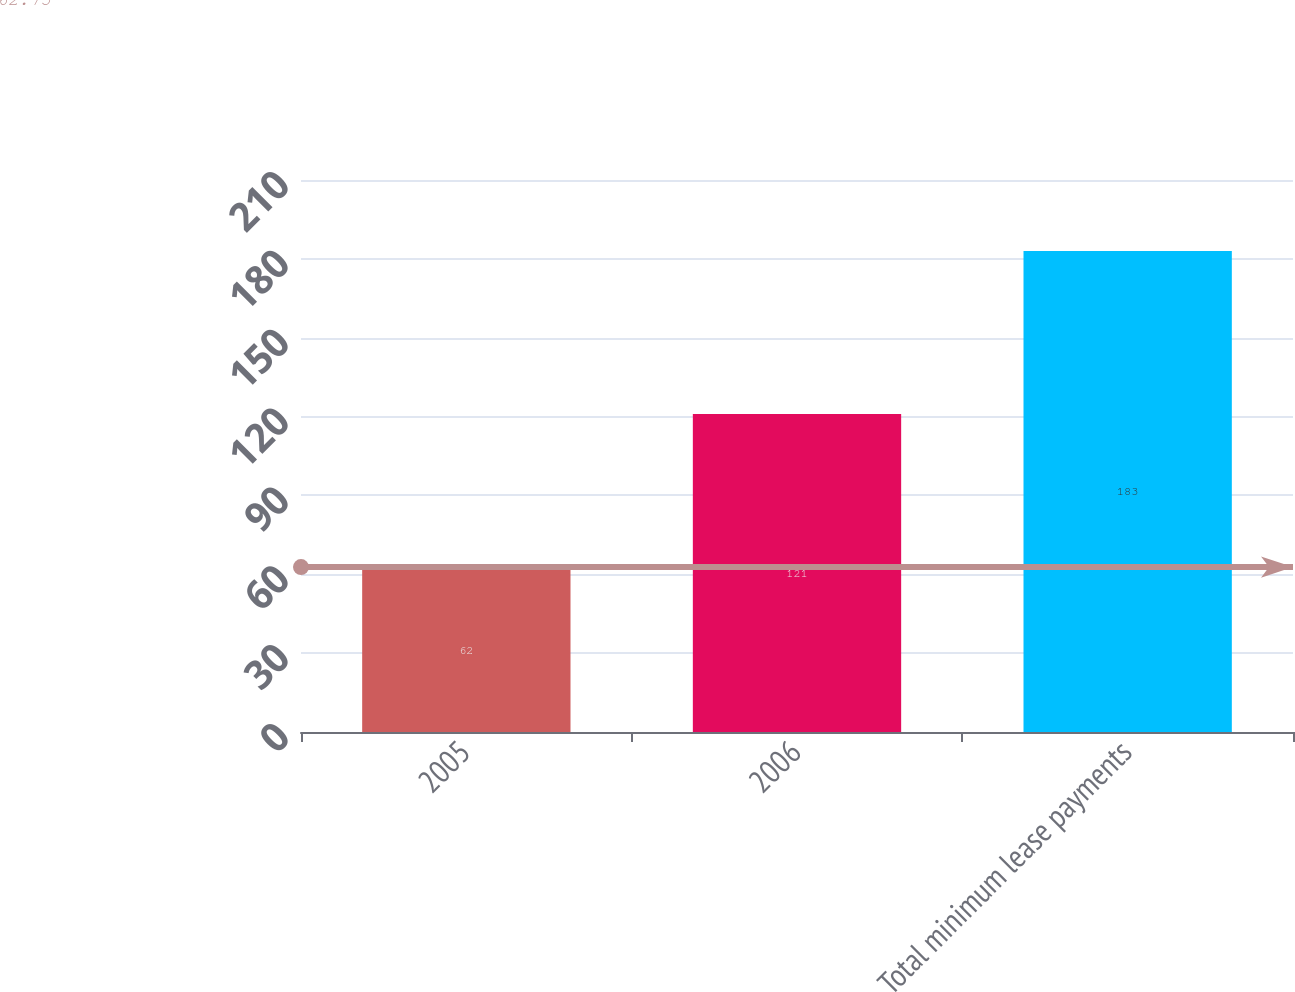Convert chart. <chart><loc_0><loc_0><loc_500><loc_500><bar_chart><fcel>2005<fcel>2006<fcel>Total minimum lease payments<nl><fcel>62<fcel>121<fcel>183<nl></chart> 